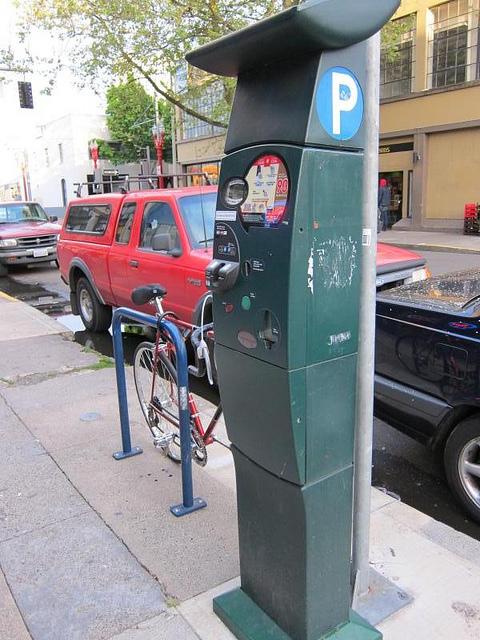Is there a red car in the image?
Short answer required. Yes. What's the white capital P stand for?
Be succinct. Parking. How many vehicles are parked on the street?
Write a very short answer. 3. 